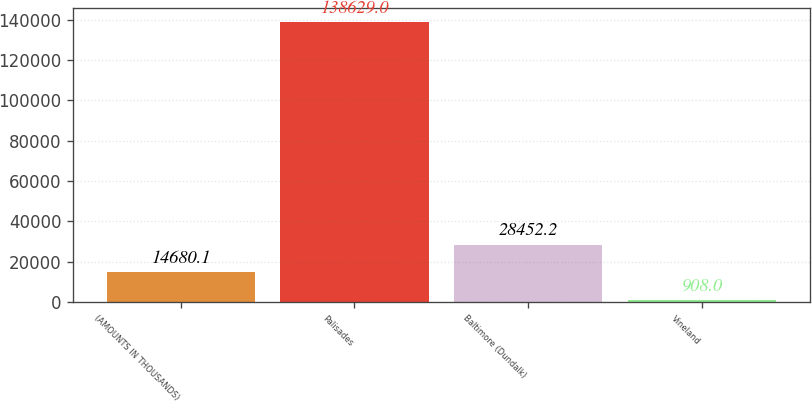<chart> <loc_0><loc_0><loc_500><loc_500><bar_chart><fcel>(AMOUNTS IN THOUSANDS)<fcel>Palisades<fcel>Baltimore (Dundalk)<fcel>Vineland<nl><fcel>14680.1<fcel>138629<fcel>28452.2<fcel>908<nl></chart> 